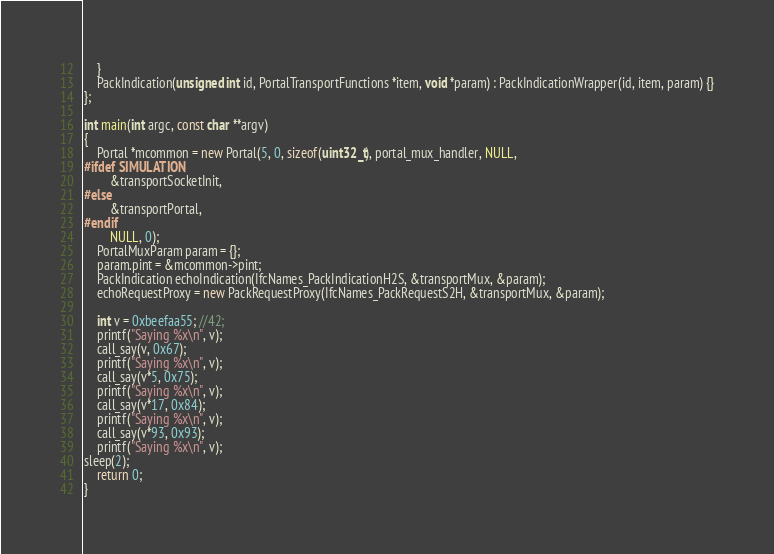Convert code to text. <code><loc_0><loc_0><loc_500><loc_500><_C++_>    }
    PackIndication(unsigned int id, PortalTransportFunctions *item, void *param) : PackIndicationWrapper(id, item, param) {}
};

int main(int argc, const char **argv)
{
    Portal *mcommon = new Portal(5, 0, sizeof(uint32_t), portal_mux_handler, NULL,
#ifdef SIMULATION
        &transportSocketInit,
#else
        &transportPortal,
#endif
        NULL, 0);
    PortalMuxParam param = {};
    param.pint = &mcommon->pint;
    PackIndication echoIndication(IfcNames_PackIndicationH2S, &transportMux, &param);
    echoRequestProxy = new PackRequestProxy(IfcNames_PackRequestS2H, &transportMux, &param);

    int v = 0xbeefaa55; //42;
    printf("Saying %x\n", v);
    call_say(v, 0x67);
    printf("Saying %x\n", v);
    call_say(v*5, 0x75);
    printf("Saying %x\n", v);
    call_say(v*17, 0x84);
    printf("Saying %x\n", v);
    call_say(v*93, 0x93);
    printf("Saying %x\n", v);
sleep(2);
    return 0;
}
</code> 